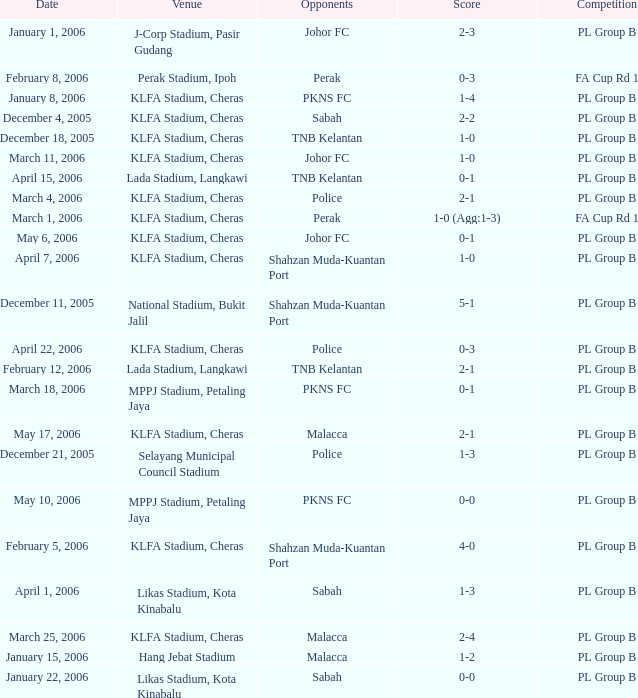Who competed on may 6, 2006? Johor FC. 